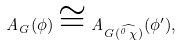Convert formula to latex. <formula><loc_0><loc_0><loc_500><loc_500>A _ { G } ( \phi ) \cong A _ { G ( \widehat { ^ { 0 } \, \chi } ) } ( \phi ^ { \prime } ) ,</formula> 